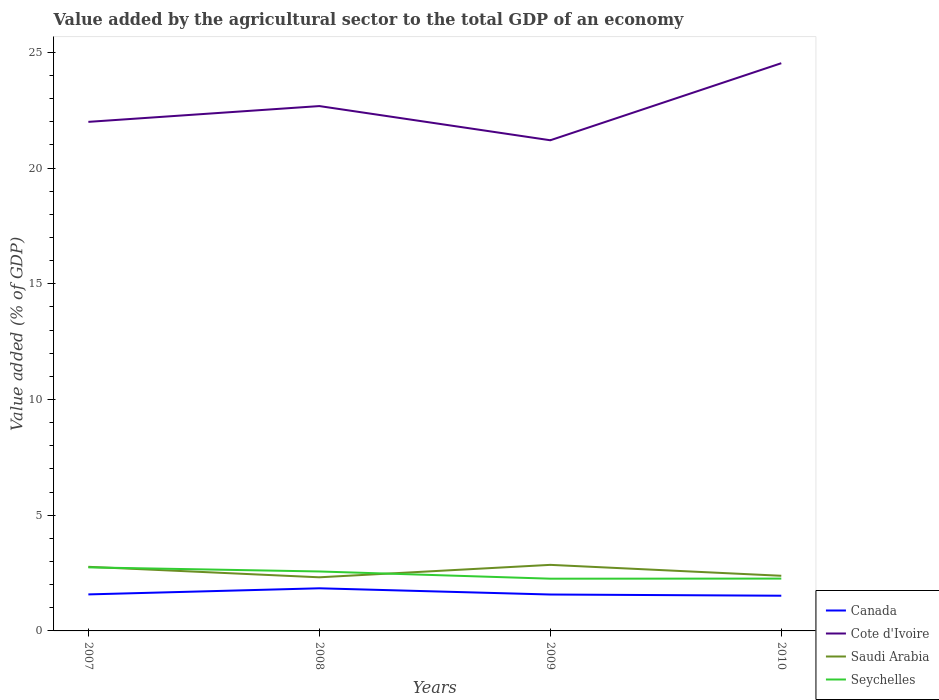Does the line corresponding to Canada intersect with the line corresponding to Saudi Arabia?
Offer a terse response. No. Across all years, what is the maximum value added by the agricultural sector to the total GDP in Canada?
Make the answer very short. 1.52. In which year was the value added by the agricultural sector to the total GDP in Saudi Arabia maximum?
Your answer should be compact. 2008. What is the total value added by the agricultural sector to the total GDP in Cote d'Ivoire in the graph?
Give a very brief answer. -0.68. What is the difference between the highest and the second highest value added by the agricultural sector to the total GDP in Cote d'Ivoire?
Provide a succinct answer. 3.33. What is the difference between the highest and the lowest value added by the agricultural sector to the total GDP in Saudi Arabia?
Provide a succinct answer. 2. How many lines are there?
Provide a succinct answer. 4. How many years are there in the graph?
Provide a short and direct response. 4. Where does the legend appear in the graph?
Your answer should be compact. Bottom right. How many legend labels are there?
Offer a very short reply. 4. What is the title of the graph?
Your answer should be very brief. Value added by the agricultural sector to the total GDP of an economy. Does "France" appear as one of the legend labels in the graph?
Your response must be concise. No. What is the label or title of the Y-axis?
Your answer should be compact. Value added (% of GDP). What is the Value added (% of GDP) in Canada in 2007?
Ensure brevity in your answer.  1.58. What is the Value added (% of GDP) in Cote d'Ivoire in 2007?
Your answer should be very brief. 21.99. What is the Value added (% of GDP) of Saudi Arabia in 2007?
Give a very brief answer. 2.77. What is the Value added (% of GDP) of Seychelles in 2007?
Give a very brief answer. 2.75. What is the Value added (% of GDP) of Canada in 2008?
Provide a short and direct response. 1.84. What is the Value added (% of GDP) of Cote d'Ivoire in 2008?
Provide a short and direct response. 22.68. What is the Value added (% of GDP) of Saudi Arabia in 2008?
Your response must be concise. 2.32. What is the Value added (% of GDP) of Seychelles in 2008?
Offer a very short reply. 2.57. What is the Value added (% of GDP) in Canada in 2009?
Make the answer very short. 1.57. What is the Value added (% of GDP) in Cote d'Ivoire in 2009?
Offer a very short reply. 21.2. What is the Value added (% of GDP) of Saudi Arabia in 2009?
Offer a terse response. 2.85. What is the Value added (% of GDP) of Seychelles in 2009?
Offer a very short reply. 2.26. What is the Value added (% of GDP) of Canada in 2010?
Provide a succinct answer. 1.52. What is the Value added (% of GDP) of Cote d'Ivoire in 2010?
Offer a terse response. 24.53. What is the Value added (% of GDP) of Saudi Arabia in 2010?
Make the answer very short. 2.38. What is the Value added (% of GDP) in Seychelles in 2010?
Give a very brief answer. 2.26. Across all years, what is the maximum Value added (% of GDP) of Canada?
Make the answer very short. 1.84. Across all years, what is the maximum Value added (% of GDP) in Cote d'Ivoire?
Provide a short and direct response. 24.53. Across all years, what is the maximum Value added (% of GDP) of Saudi Arabia?
Provide a succinct answer. 2.85. Across all years, what is the maximum Value added (% of GDP) of Seychelles?
Offer a very short reply. 2.75. Across all years, what is the minimum Value added (% of GDP) in Canada?
Make the answer very short. 1.52. Across all years, what is the minimum Value added (% of GDP) in Cote d'Ivoire?
Your answer should be compact. 21.2. Across all years, what is the minimum Value added (% of GDP) of Saudi Arabia?
Offer a terse response. 2.32. Across all years, what is the minimum Value added (% of GDP) of Seychelles?
Give a very brief answer. 2.26. What is the total Value added (% of GDP) in Canada in the graph?
Make the answer very short. 6.51. What is the total Value added (% of GDP) in Cote d'Ivoire in the graph?
Provide a succinct answer. 90.4. What is the total Value added (% of GDP) of Saudi Arabia in the graph?
Give a very brief answer. 10.32. What is the total Value added (% of GDP) in Seychelles in the graph?
Your answer should be compact. 9.83. What is the difference between the Value added (% of GDP) of Canada in 2007 and that in 2008?
Provide a short and direct response. -0.26. What is the difference between the Value added (% of GDP) of Cote d'Ivoire in 2007 and that in 2008?
Your answer should be very brief. -0.68. What is the difference between the Value added (% of GDP) in Saudi Arabia in 2007 and that in 2008?
Your answer should be compact. 0.45. What is the difference between the Value added (% of GDP) of Seychelles in 2007 and that in 2008?
Offer a terse response. 0.18. What is the difference between the Value added (% of GDP) of Canada in 2007 and that in 2009?
Offer a very short reply. 0.01. What is the difference between the Value added (% of GDP) of Cote d'Ivoire in 2007 and that in 2009?
Your answer should be compact. 0.79. What is the difference between the Value added (% of GDP) of Saudi Arabia in 2007 and that in 2009?
Offer a terse response. -0.08. What is the difference between the Value added (% of GDP) of Seychelles in 2007 and that in 2009?
Your response must be concise. 0.49. What is the difference between the Value added (% of GDP) of Canada in 2007 and that in 2010?
Your answer should be compact. 0.06. What is the difference between the Value added (% of GDP) of Cote d'Ivoire in 2007 and that in 2010?
Your answer should be very brief. -2.53. What is the difference between the Value added (% of GDP) of Saudi Arabia in 2007 and that in 2010?
Give a very brief answer. 0.39. What is the difference between the Value added (% of GDP) in Seychelles in 2007 and that in 2010?
Provide a short and direct response. 0.49. What is the difference between the Value added (% of GDP) of Canada in 2008 and that in 2009?
Your answer should be very brief. 0.27. What is the difference between the Value added (% of GDP) in Cote d'Ivoire in 2008 and that in 2009?
Your answer should be compact. 1.48. What is the difference between the Value added (% of GDP) of Saudi Arabia in 2008 and that in 2009?
Ensure brevity in your answer.  -0.54. What is the difference between the Value added (% of GDP) of Seychelles in 2008 and that in 2009?
Offer a very short reply. 0.31. What is the difference between the Value added (% of GDP) in Canada in 2008 and that in 2010?
Give a very brief answer. 0.32. What is the difference between the Value added (% of GDP) of Cote d'Ivoire in 2008 and that in 2010?
Provide a succinct answer. -1.85. What is the difference between the Value added (% of GDP) in Saudi Arabia in 2008 and that in 2010?
Your response must be concise. -0.07. What is the difference between the Value added (% of GDP) of Seychelles in 2008 and that in 2010?
Keep it short and to the point. 0.31. What is the difference between the Value added (% of GDP) in Canada in 2009 and that in 2010?
Keep it short and to the point. 0.05. What is the difference between the Value added (% of GDP) in Cote d'Ivoire in 2009 and that in 2010?
Make the answer very short. -3.33. What is the difference between the Value added (% of GDP) in Saudi Arabia in 2009 and that in 2010?
Offer a terse response. 0.47. What is the difference between the Value added (% of GDP) in Seychelles in 2009 and that in 2010?
Make the answer very short. -0. What is the difference between the Value added (% of GDP) in Canada in 2007 and the Value added (% of GDP) in Cote d'Ivoire in 2008?
Offer a terse response. -21.1. What is the difference between the Value added (% of GDP) in Canada in 2007 and the Value added (% of GDP) in Saudi Arabia in 2008?
Offer a terse response. -0.74. What is the difference between the Value added (% of GDP) of Canada in 2007 and the Value added (% of GDP) of Seychelles in 2008?
Your answer should be very brief. -0.99. What is the difference between the Value added (% of GDP) of Cote d'Ivoire in 2007 and the Value added (% of GDP) of Saudi Arabia in 2008?
Make the answer very short. 19.68. What is the difference between the Value added (% of GDP) in Cote d'Ivoire in 2007 and the Value added (% of GDP) in Seychelles in 2008?
Offer a very short reply. 19.43. What is the difference between the Value added (% of GDP) in Saudi Arabia in 2007 and the Value added (% of GDP) in Seychelles in 2008?
Ensure brevity in your answer.  0.2. What is the difference between the Value added (% of GDP) in Canada in 2007 and the Value added (% of GDP) in Cote d'Ivoire in 2009?
Your answer should be very brief. -19.62. What is the difference between the Value added (% of GDP) of Canada in 2007 and the Value added (% of GDP) of Saudi Arabia in 2009?
Offer a terse response. -1.28. What is the difference between the Value added (% of GDP) in Canada in 2007 and the Value added (% of GDP) in Seychelles in 2009?
Your response must be concise. -0.68. What is the difference between the Value added (% of GDP) in Cote d'Ivoire in 2007 and the Value added (% of GDP) in Saudi Arabia in 2009?
Your answer should be compact. 19.14. What is the difference between the Value added (% of GDP) in Cote d'Ivoire in 2007 and the Value added (% of GDP) in Seychelles in 2009?
Provide a short and direct response. 19.74. What is the difference between the Value added (% of GDP) of Saudi Arabia in 2007 and the Value added (% of GDP) of Seychelles in 2009?
Keep it short and to the point. 0.51. What is the difference between the Value added (% of GDP) of Canada in 2007 and the Value added (% of GDP) of Cote d'Ivoire in 2010?
Ensure brevity in your answer.  -22.95. What is the difference between the Value added (% of GDP) in Canada in 2007 and the Value added (% of GDP) in Saudi Arabia in 2010?
Ensure brevity in your answer.  -0.8. What is the difference between the Value added (% of GDP) of Canada in 2007 and the Value added (% of GDP) of Seychelles in 2010?
Provide a succinct answer. -0.68. What is the difference between the Value added (% of GDP) of Cote d'Ivoire in 2007 and the Value added (% of GDP) of Saudi Arabia in 2010?
Give a very brief answer. 19.61. What is the difference between the Value added (% of GDP) in Cote d'Ivoire in 2007 and the Value added (% of GDP) in Seychelles in 2010?
Your answer should be very brief. 19.73. What is the difference between the Value added (% of GDP) in Saudi Arabia in 2007 and the Value added (% of GDP) in Seychelles in 2010?
Your response must be concise. 0.51. What is the difference between the Value added (% of GDP) in Canada in 2008 and the Value added (% of GDP) in Cote d'Ivoire in 2009?
Offer a terse response. -19.36. What is the difference between the Value added (% of GDP) in Canada in 2008 and the Value added (% of GDP) in Saudi Arabia in 2009?
Give a very brief answer. -1.01. What is the difference between the Value added (% of GDP) in Canada in 2008 and the Value added (% of GDP) in Seychelles in 2009?
Offer a very short reply. -0.42. What is the difference between the Value added (% of GDP) of Cote d'Ivoire in 2008 and the Value added (% of GDP) of Saudi Arabia in 2009?
Ensure brevity in your answer.  19.82. What is the difference between the Value added (% of GDP) in Cote d'Ivoire in 2008 and the Value added (% of GDP) in Seychelles in 2009?
Your answer should be compact. 20.42. What is the difference between the Value added (% of GDP) of Saudi Arabia in 2008 and the Value added (% of GDP) of Seychelles in 2009?
Your response must be concise. 0.06. What is the difference between the Value added (% of GDP) in Canada in 2008 and the Value added (% of GDP) in Cote d'Ivoire in 2010?
Your response must be concise. -22.69. What is the difference between the Value added (% of GDP) in Canada in 2008 and the Value added (% of GDP) in Saudi Arabia in 2010?
Offer a very short reply. -0.54. What is the difference between the Value added (% of GDP) in Canada in 2008 and the Value added (% of GDP) in Seychelles in 2010?
Make the answer very short. -0.42. What is the difference between the Value added (% of GDP) of Cote d'Ivoire in 2008 and the Value added (% of GDP) of Saudi Arabia in 2010?
Give a very brief answer. 20.29. What is the difference between the Value added (% of GDP) of Cote d'Ivoire in 2008 and the Value added (% of GDP) of Seychelles in 2010?
Provide a short and direct response. 20.42. What is the difference between the Value added (% of GDP) of Saudi Arabia in 2008 and the Value added (% of GDP) of Seychelles in 2010?
Your answer should be compact. 0.06. What is the difference between the Value added (% of GDP) of Canada in 2009 and the Value added (% of GDP) of Cote d'Ivoire in 2010?
Offer a very short reply. -22.96. What is the difference between the Value added (% of GDP) of Canada in 2009 and the Value added (% of GDP) of Saudi Arabia in 2010?
Offer a terse response. -0.81. What is the difference between the Value added (% of GDP) of Canada in 2009 and the Value added (% of GDP) of Seychelles in 2010?
Keep it short and to the point. -0.69. What is the difference between the Value added (% of GDP) of Cote d'Ivoire in 2009 and the Value added (% of GDP) of Saudi Arabia in 2010?
Your answer should be compact. 18.82. What is the difference between the Value added (% of GDP) in Cote d'Ivoire in 2009 and the Value added (% of GDP) in Seychelles in 2010?
Ensure brevity in your answer.  18.94. What is the difference between the Value added (% of GDP) of Saudi Arabia in 2009 and the Value added (% of GDP) of Seychelles in 2010?
Your answer should be very brief. 0.59. What is the average Value added (% of GDP) of Canada per year?
Keep it short and to the point. 1.63. What is the average Value added (% of GDP) of Cote d'Ivoire per year?
Your answer should be compact. 22.6. What is the average Value added (% of GDP) in Saudi Arabia per year?
Provide a succinct answer. 2.58. What is the average Value added (% of GDP) of Seychelles per year?
Offer a very short reply. 2.46. In the year 2007, what is the difference between the Value added (% of GDP) in Canada and Value added (% of GDP) in Cote d'Ivoire?
Give a very brief answer. -20.42. In the year 2007, what is the difference between the Value added (% of GDP) of Canada and Value added (% of GDP) of Saudi Arabia?
Give a very brief answer. -1.19. In the year 2007, what is the difference between the Value added (% of GDP) in Canada and Value added (% of GDP) in Seychelles?
Offer a very short reply. -1.17. In the year 2007, what is the difference between the Value added (% of GDP) in Cote d'Ivoire and Value added (% of GDP) in Saudi Arabia?
Your answer should be compact. 19.22. In the year 2007, what is the difference between the Value added (% of GDP) of Cote d'Ivoire and Value added (% of GDP) of Seychelles?
Provide a succinct answer. 19.25. In the year 2007, what is the difference between the Value added (% of GDP) in Saudi Arabia and Value added (% of GDP) in Seychelles?
Your answer should be compact. 0.02. In the year 2008, what is the difference between the Value added (% of GDP) of Canada and Value added (% of GDP) of Cote d'Ivoire?
Give a very brief answer. -20.84. In the year 2008, what is the difference between the Value added (% of GDP) in Canada and Value added (% of GDP) in Saudi Arabia?
Your answer should be very brief. -0.47. In the year 2008, what is the difference between the Value added (% of GDP) of Canada and Value added (% of GDP) of Seychelles?
Ensure brevity in your answer.  -0.73. In the year 2008, what is the difference between the Value added (% of GDP) in Cote d'Ivoire and Value added (% of GDP) in Saudi Arabia?
Provide a short and direct response. 20.36. In the year 2008, what is the difference between the Value added (% of GDP) in Cote d'Ivoire and Value added (% of GDP) in Seychelles?
Give a very brief answer. 20.11. In the year 2008, what is the difference between the Value added (% of GDP) in Saudi Arabia and Value added (% of GDP) in Seychelles?
Your response must be concise. -0.25. In the year 2009, what is the difference between the Value added (% of GDP) of Canada and Value added (% of GDP) of Cote d'Ivoire?
Your answer should be compact. -19.63. In the year 2009, what is the difference between the Value added (% of GDP) of Canada and Value added (% of GDP) of Saudi Arabia?
Provide a succinct answer. -1.28. In the year 2009, what is the difference between the Value added (% of GDP) in Canada and Value added (% of GDP) in Seychelles?
Provide a short and direct response. -0.68. In the year 2009, what is the difference between the Value added (% of GDP) of Cote d'Ivoire and Value added (% of GDP) of Saudi Arabia?
Keep it short and to the point. 18.35. In the year 2009, what is the difference between the Value added (% of GDP) of Cote d'Ivoire and Value added (% of GDP) of Seychelles?
Make the answer very short. 18.94. In the year 2009, what is the difference between the Value added (% of GDP) of Saudi Arabia and Value added (% of GDP) of Seychelles?
Your answer should be very brief. 0.6. In the year 2010, what is the difference between the Value added (% of GDP) in Canada and Value added (% of GDP) in Cote d'Ivoire?
Provide a succinct answer. -23.01. In the year 2010, what is the difference between the Value added (% of GDP) of Canada and Value added (% of GDP) of Saudi Arabia?
Offer a very short reply. -0.86. In the year 2010, what is the difference between the Value added (% of GDP) of Canada and Value added (% of GDP) of Seychelles?
Your response must be concise. -0.74. In the year 2010, what is the difference between the Value added (% of GDP) of Cote d'Ivoire and Value added (% of GDP) of Saudi Arabia?
Provide a short and direct response. 22.15. In the year 2010, what is the difference between the Value added (% of GDP) of Cote d'Ivoire and Value added (% of GDP) of Seychelles?
Provide a short and direct response. 22.27. In the year 2010, what is the difference between the Value added (% of GDP) in Saudi Arabia and Value added (% of GDP) in Seychelles?
Keep it short and to the point. 0.12. What is the ratio of the Value added (% of GDP) of Canada in 2007 to that in 2008?
Offer a very short reply. 0.86. What is the ratio of the Value added (% of GDP) of Cote d'Ivoire in 2007 to that in 2008?
Your answer should be very brief. 0.97. What is the ratio of the Value added (% of GDP) of Saudi Arabia in 2007 to that in 2008?
Your answer should be compact. 1.2. What is the ratio of the Value added (% of GDP) of Seychelles in 2007 to that in 2008?
Ensure brevity in your answer.  1.07. What is the ratio of the Value added (% of GDP) of Cote d'Ivoire in 2007 to that in 2009?
Provide a succinct answer. 1.04. What is the ratio of the Value added (% of GDP) in Saudi Arabia in 2007 to that in 2009?
Ensure brevity in your answer.  0.97. What is the ratio of the Value added (% of GDP) in Seychelles in 2007 to that in 2009?
Make the answer very short. 1.22. What is the ratio of the Value added (% of GDP) of Canada in 2007 to that in 2010?
Provide a short and direct response. 1.04. What is the ratio of the Value added (% of GDP) of Cote d'Ivoire in 2007 to that in 2010?
Offer a very short reply. 0.9. What is the ratio of the Value added (% of GDP) in Saudi Arabia in 2007 to that in 2010?
Provide a short and direct response. 1.16. What is the ratio of the Value added (% of GDP) in Seychelles in 2007 to that in 2010?
Ensure brevity in your answer.  1.21. What is the ratio of the Value added (% of GDP) in Canada in 2008 to that in 2009?
Your answer should be compact. 1.17. What is the ratio of the Value added (% of GDP) of Cote d'Ivoire in 2008 to that in 2009?
Provide a short and direct response. 1.07. What is the ratio of the Value added (% of GDP) in Saudi Arabia in 2008 to that in 2009?
Your response must be concise. 0.81. What is the ratio of the Value added (% of GDP) of Seychelles in 2008 to that in 2009?
Make the answer very short. 1.14. What is the ratio of the Value added (% of GDP) of Canada in 2008 to that in 2010?
Keep it short and to the point. 1.21. What is the ratio of the Value added (% of GDP) in Cote d'Ivoire in 2008 to that in 2010?
Ensure brevity in your answer.  0.92. What is the ratio of the Value added (% of GDP) in Saudi Arabia in 2008 to that in 2010?
Offer a very short reply. 0.97. What is the ratio of the Value added (% of GDP) in Seychelles in 2008 to that in 2010?
Keep it short and to the point. 1.14. What is the ratio of the Value added (% of GDP) in Canada in 2009 to that in 2010?
Provide a succinct answer. 1.03. What is the ratio of the Value added (% of GDP) of Cote d'Ivoire in 2009 to that in 2010?
Provide a succinct answer. 0.86. What is the ratio of the Value added (% of GDP) in Saudi Arabia in 2009 to that in 2010?
Provide a succinct answer. 1.2. What is the difference between the highest and the second highest Value added (% of GDP) of Canada?
Keep it short and to the point. 0.26. What is the difference between the highest and the second highest Value added (% of GDP) of Cote d'Ivoire?
Provide a succinct answer. 1.85. What is the difference between the highest and the second highest Value added (% of GDP) of Saudi Arabia?
Provide a succinct answer. 0.08. What is the difference between the highest and the second highest Value added (% of GDP) in Seychelles?
Provide a short and direct response. 0.18. What is the difference between the highest and the lowest Value added (% of GDP) of Canada?
Ensure brevity in your answer.  0.32. What is the difference between the highest and the lowest Value added (% of GDP) of Cote d'Ivoire?
Your answer should be compact. 3.33. What is the difference between the highest and the lowest Value added (% of GDP) in Saudi Arabia?
Make the answer very short. 0.54. What is the difference between the highest and the lowest Value added (% of GDP) in Seychelles?
Offer a terse response. 0.49. 